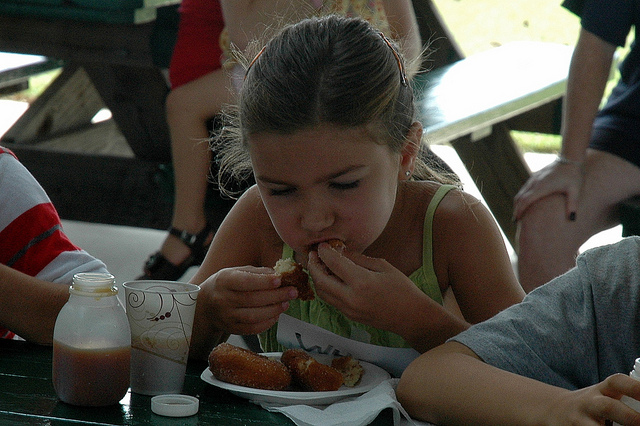Are there any indications of the time of day or year in this photo? The lighting in the photo suggests daytime, with enough sunlight to indicate either late morning or afternoon. There aren't any clear indications of the season, but the attire of the girl, wearing a sleeveless top, suggests it could be warm weather, leaning towards late spring or summer. 